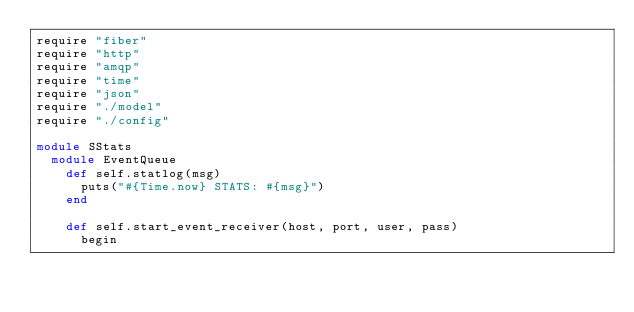<code> <loc_0><loc_0><loc_500><loc_500><_Crystal_>require "fiber"
require "http"
require "amqp"
require "time"
require "json"
require "./model"
require "./config"

module SStats
  module EventQueue
    def self.statlog(msg)
      puts("#{Time.now} STATS: #{msg}")
    end

    def self.start_event_receiver(host, port, user, pass)
      begin</code> 